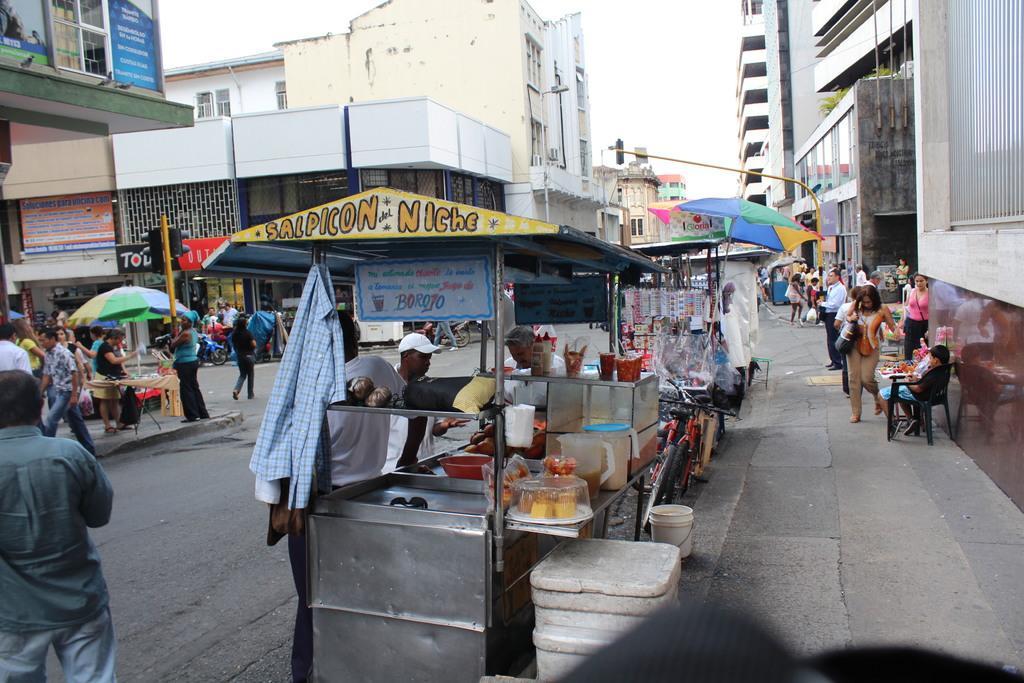How would you summarize this image in a sentence or two? In this image there is a shop in the bottom of this image and there are some buildings in the background. There are some persons standing on the left side of this image and on the right side of this image as well. There is a sky on the top of this image. 